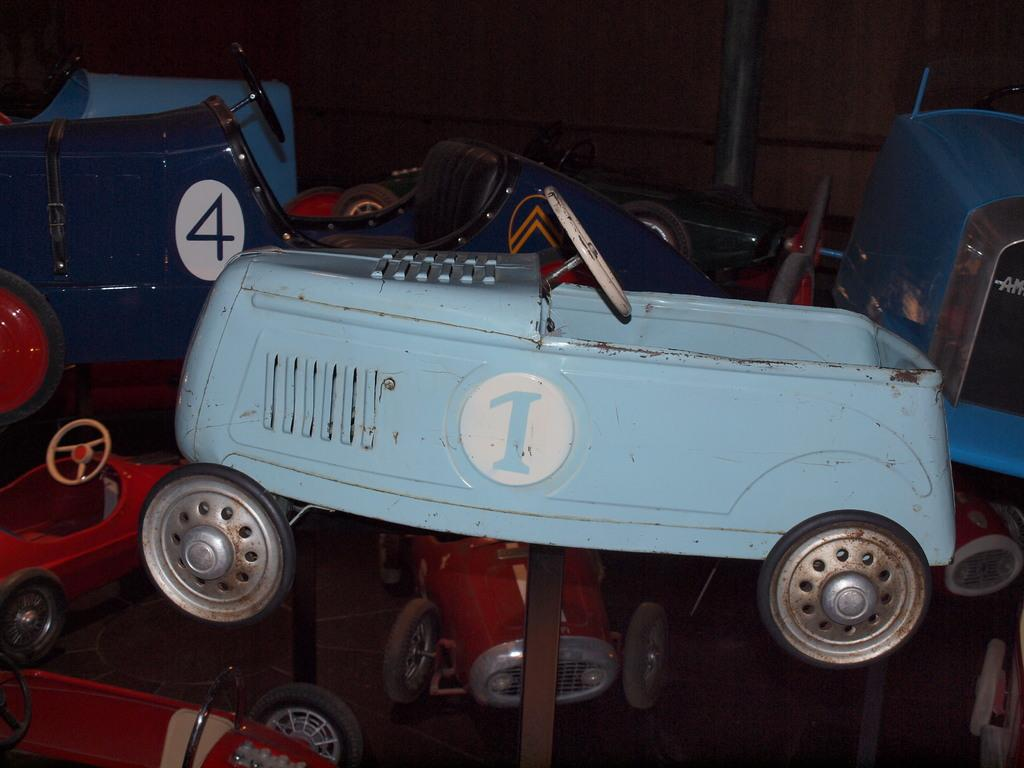What type of toys are present in the image? There are toy cars in the image. How are the toy cars arranged or displayed? The toy cars are on iron rods. What can be seen in the background of the image? There is a wooden board and a pole in the background of the image. What sound does the thunder make in the image? There is no thunder present in the image; it only features toy cars on iron rods, a wooden board, and a pole in the background. 